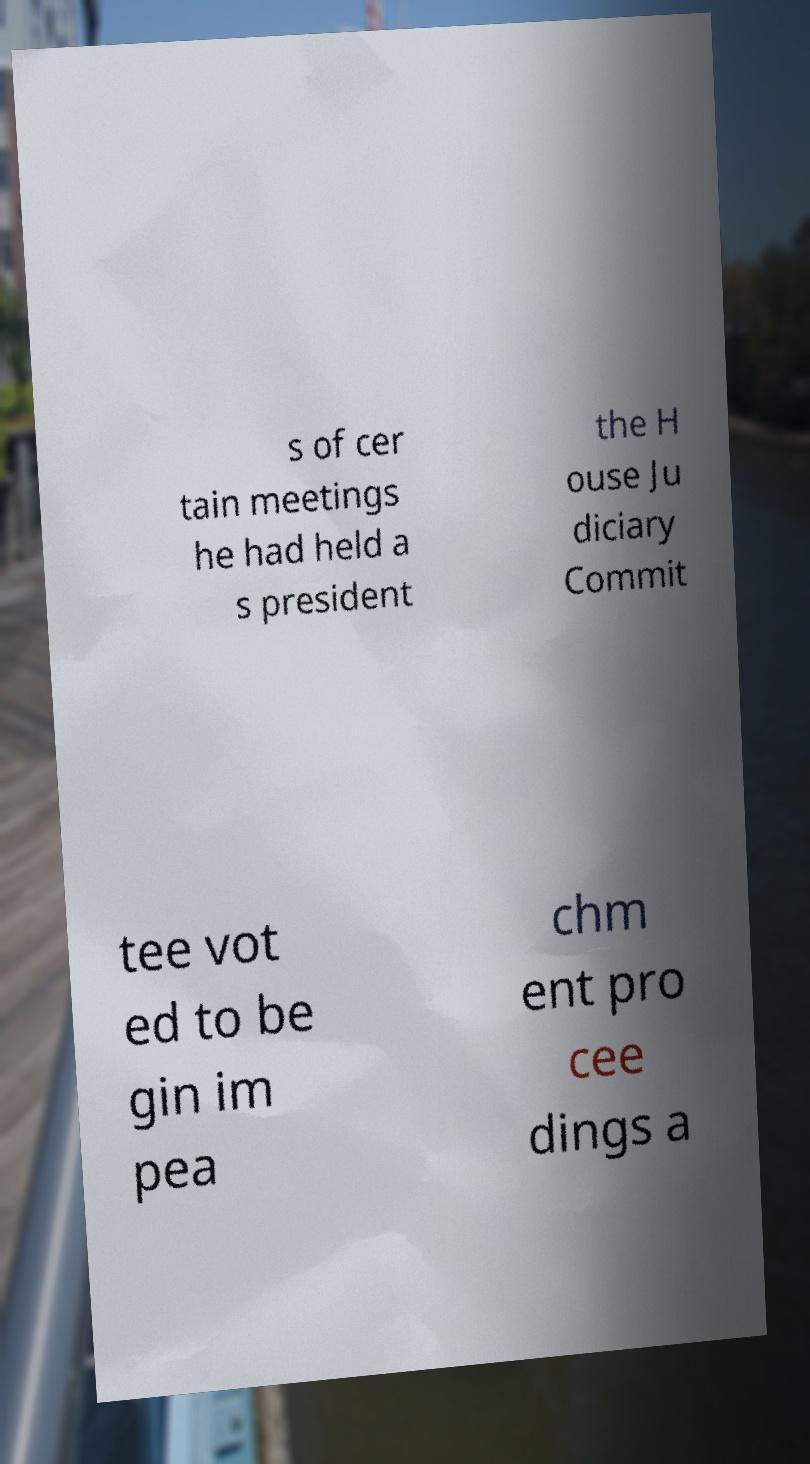Can you read and provide the text displayed in the image?This photo seems to have some interesting text. Can you extract and type it out for me? s of cer tain meetings he had held a s president the H ouse Ju diciary Commit tee vot ed to be gin im pea chm ent pro cee dings a 